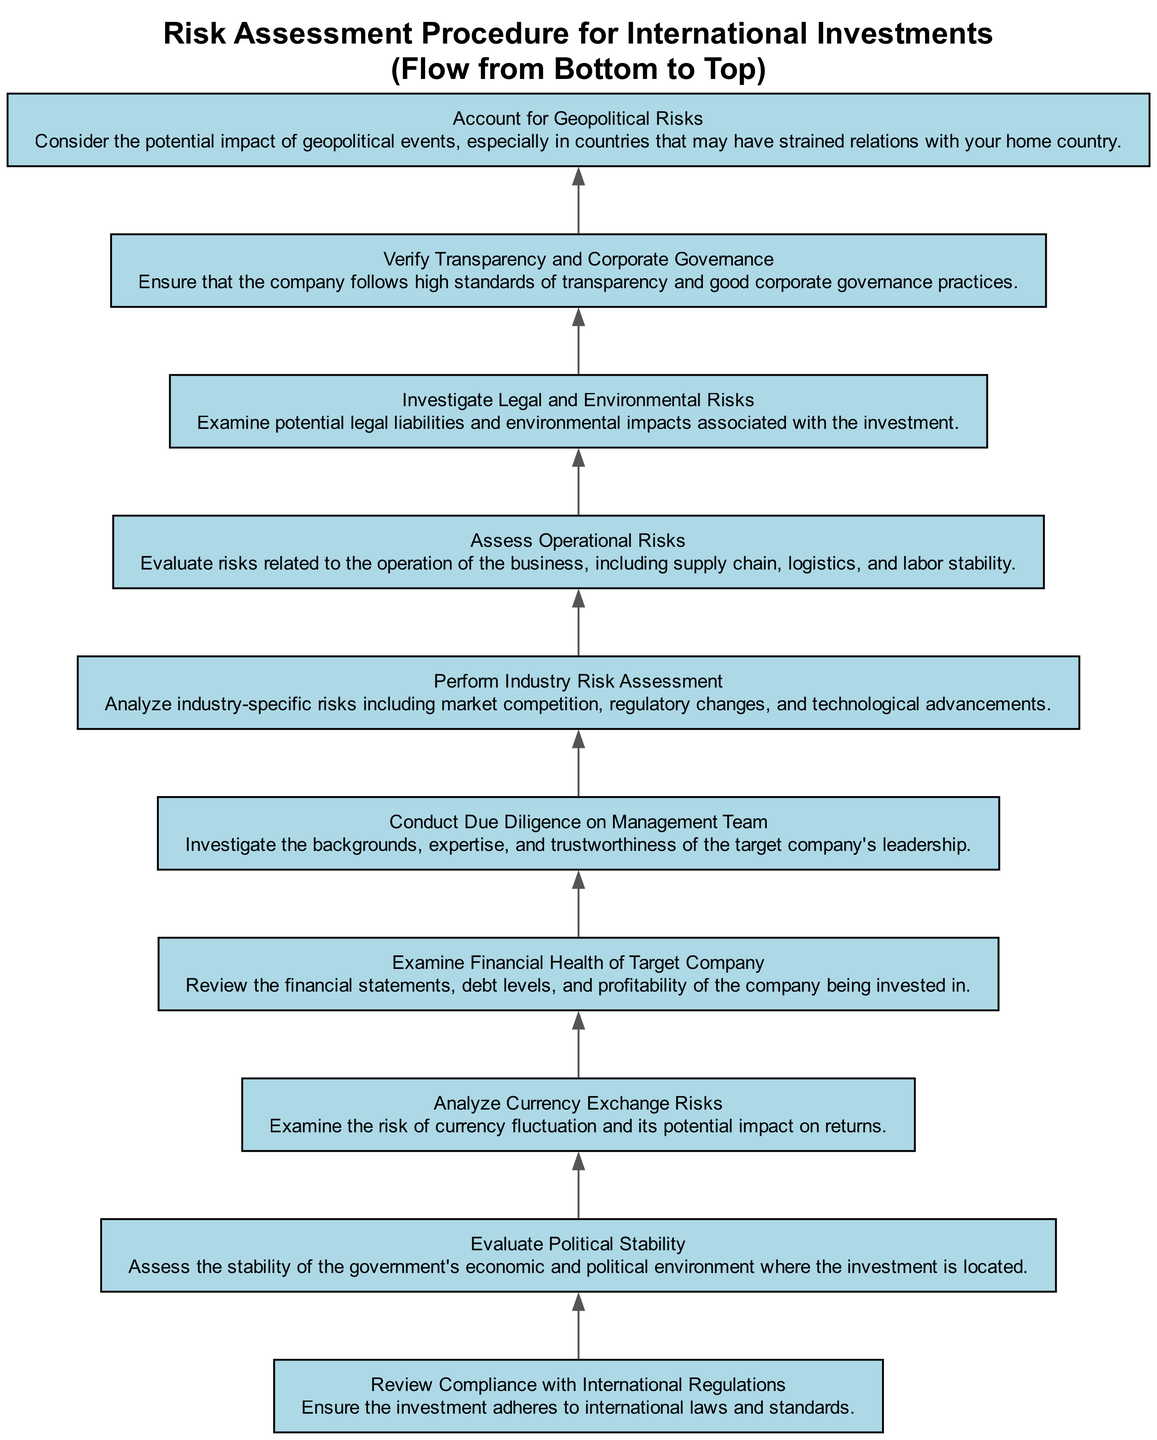What is the first element in the flowchart? The first element is "Verify Transparency and Corporate Governance," as it is positioned at the bottommost part of the diagram.
Answer: Verify Transparency and Corporate Governance How many total elements are in the diagram? By counting the nodes from the provided data, there are 10 elements represented in the diagram.
Answer: 10 What does the second element assess? The second element, "Account for Geopolitical Risks," assesses the potential impact of geopolitical events, especially in relationships with other countries.
Answer: Potential impact of geopolitical events Which two elements are directly connected? "Examine Financial Health of Target Company" is directly connected to "Conduct Due Diligence on Management Team," indicating a flow from assessing financial health to management scrutiny.
Answer: Examine Financial Health of Target Company and Conduct Due Diligence on Management Team Which element relates to the stability of a government? The element "Evaluate Political Stability" relates to assessing the stability of the government's economic and political environment where the investment is located.
Answer: Evaluate Political Stability What is the last node in the flowchart? The last node is "Review Compliance with International Regulations," as it is the topmost element in the flow when following the upward direction of the diagram.
Answer: Review Compliance with International Regulations What type of risks does the "Perform Industry Risk Assessment" examine? The "Perform Industry Risk Assessment" examines industry-specific risks, including market competition, regulatory changes, and technological advancements, indicating its broad focus on industry context.
Answer: Industry-specific risks Which element is concerned with currency risks? "Analyze Currency Exchange Risks" specifically addresses the risks associated with currency fluctuations and their impact on investment returns.
Answer: Analyze Currency Exchange Risks How are the elements organized in the diagram? The elements are organized to flow from bottom to top, indicating a sequential risk assessment process that builds on each preceding evaluation.
Answer: Bottom to top 